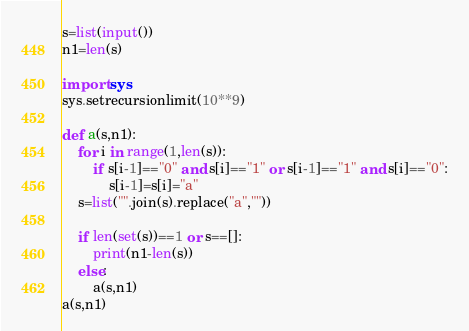<code> <loc_0><loc_0><loc_500><loc_500><_Python_>s=list(input())
n1=len(s)

import sys
sys.setrecursionlimit(10**9)

def a(s,n1):
    for i in range(1,len(s)):
        if s[i-1]=="0" and s[i]=="1" or s[i-1]=="1" and s[i]=="0":
            s[i-1]=s[i]="a"
    s=list("".join(s).replace("a",""))
    
    if len(set(s))==1 or s==[]:
        print(n1-len(s))
    else:
        a(s,n1)
a(s,n1)    
</code> 